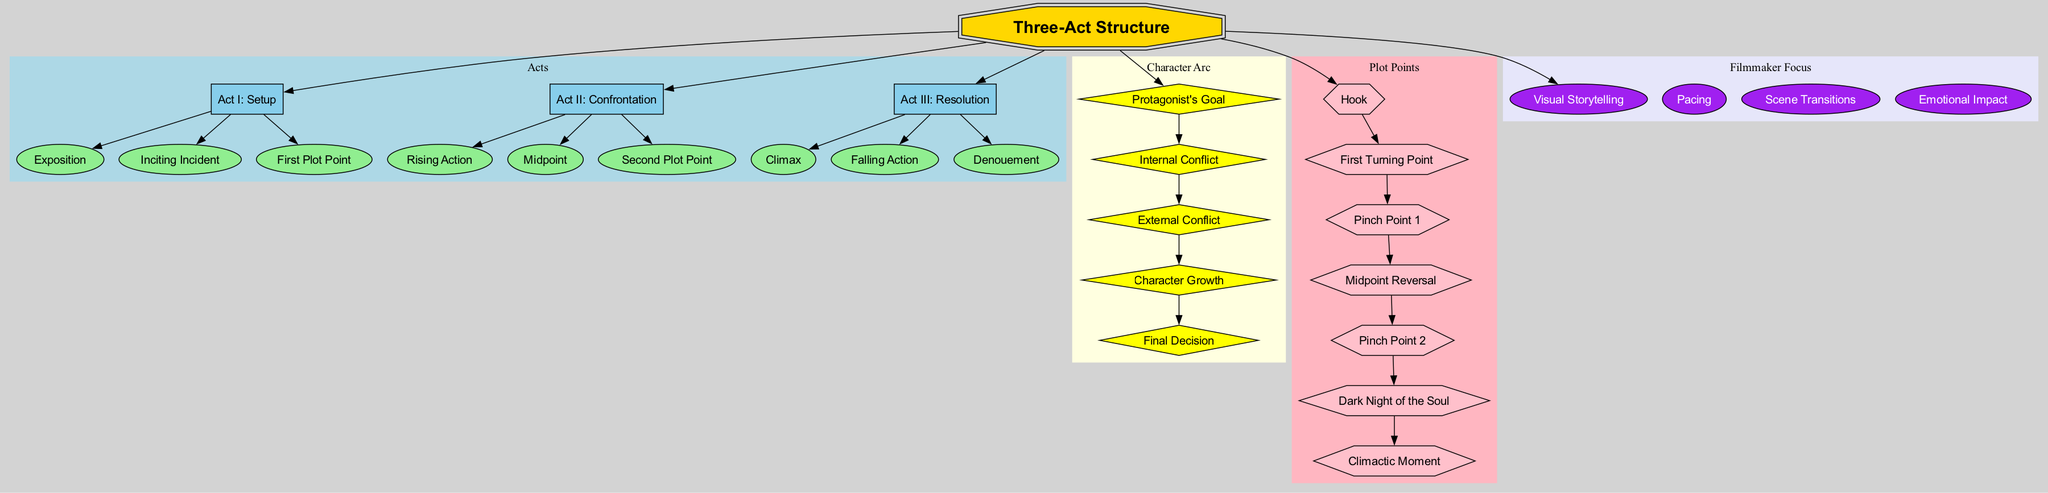What are the three acts in the diagram? The diagram presents three acts labeled as "Act I: Setup," "Act II: Confrontation," and "Act III: Resolution." These acts are clearly defined as the main structural components of the three-act structure.
Answer: Act I: Setup, Act II: Confrontation, Act III: Resolution What element comes after the Inciting Incident? The Inciting Incident is part of Act I: Setup, and the next key element that follows it is "First Plot Point." This can be deduced by looking at the flow of elements connected to Act I.
Answer: First Plot Point How many key elements are there in Act II: Confrontation? Act II: Confrontation includes three key elements: "Rising Action," "Midpoint," and "Second Plot Point." By counting the listed elements under Act II in the diagram, we reach this conclusion.
Answer: Three What is the relationship between Climax and Falling Action? The Climax is the last key element in Act III: Resolution, followed by Falling Action. This flow indicates that Falling Action directly comes after Climax, showcasing their sequential relationship in the resolution phase of the narrative.
Answer: Falling Action Which plot point is known as the midpoint? The "Midpoint" is one of the key plot points specifically identified in the diagram. It is labeled among other plot points, which makes it distinct and straightforward; thus, it's referred to simply as "Midpoint."
Answer: Midpoint What is the first Focus area mentioned in the Filmmaker Focus section? The first Focus area is "Visual Storytelling." This can be identified by examining the nodes listed under the Filmmaker Focus category, where this is the first in the sequence.
Answer: Visual Storytelling How many more plot points are there after Pinch Point 1? There are three plot points that come after Pinch Point 1: "Midpoint Reversal," "Pinch Point 2," and "Dark Night of the Soul." Counting these points sequentially gives us this total.
Answer: Three What defines the External Conflict in the Character Arc? The External Conflict is listed as one of the key components in the Character Arc section of the diagram. It tells us about the challenges that the protagonist faces apart from their internal struggles.
Answer: External Conflict Which act culminates in the Denouement? Act III: Resolution concludes with the Denouement, which follows after the Climax and Falling Action. The connection of these elements in the final act makes it clear that Denouement is its concluding part.
Answer: Act III: Resolution 